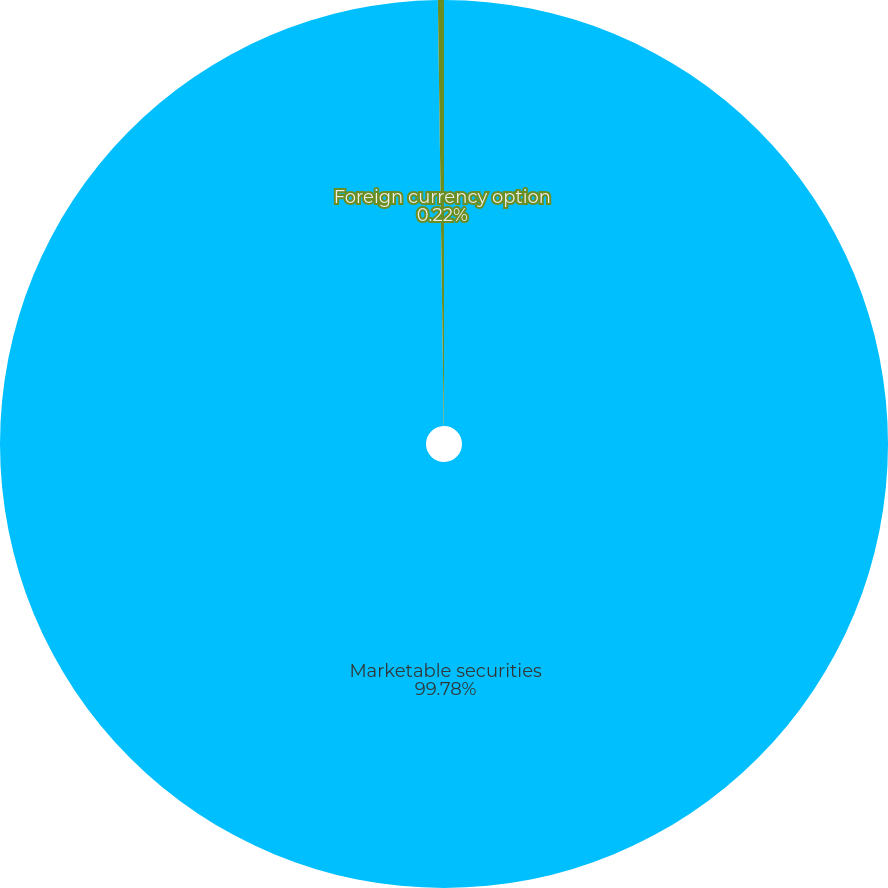Convert chart to OTSL. <chart><loc_0><loc_0><loc_500><loc_500><pie_chart><fcel>Marketable securities<fcel>Foreign currency option<nl><fcel>99.78%<fcel>0.22%<nl></chart> 